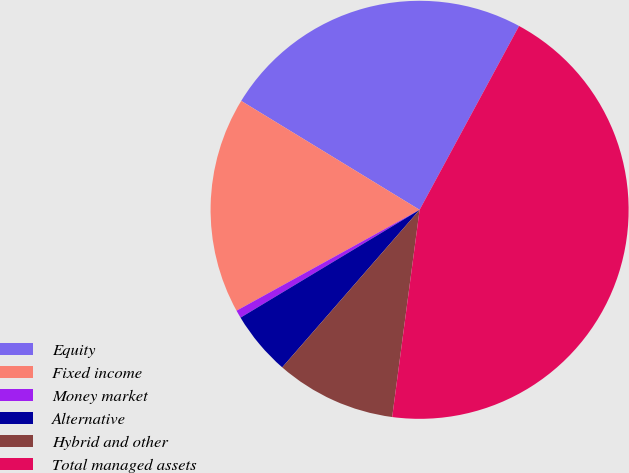<chart> <loc_0><loc_0><loc_500><loc_500><pie_chart><fcel>Equity<fcel>Fixed income<fcel>Money market<fcel>Alternative<fcel>Hybrid and other<fcel>Total managed assets<nl><fcel>24.17%<fcel>16.74%<fcel>0.61%<fcel>4.96%<fcel>9.32%<fcel>44.2%<nl></chart> 